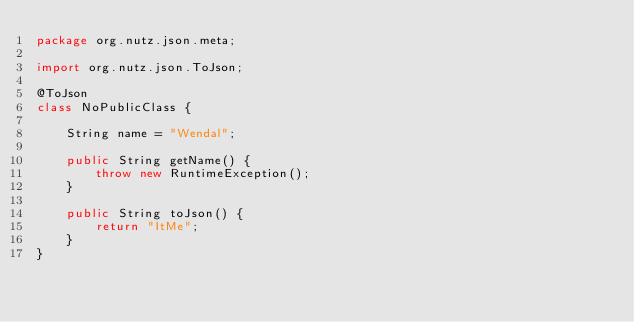<code> <loc_0><loc_0><loc_500><loc_500><_Java_>package org.nutz.json.meta;

import org.nutz.json.ToJson;

@ToJson
class NoPublicClass {

    String name = "Wendal";
    
    public String getName() {
        throw new RuntimeException();
    }
    
    public String toJson() {
        return "ItMe";
    }
}
</code> 